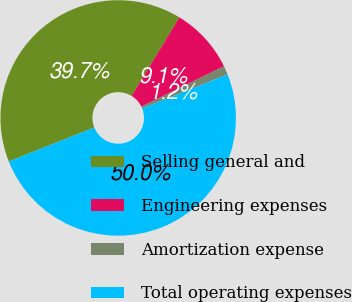Convert chart to OTSL. <chart><loc_0><loc_0><loc_500><loc_500><pie_chart><fcel>Selling general and<fcel>Engineering expenses<fcel>Amortization expense<fcel>Total operating expenses<nl><fcel>39.73%<fcel>9.08%<fcel>1.19%<fcel>50.0%<nl></chart> 